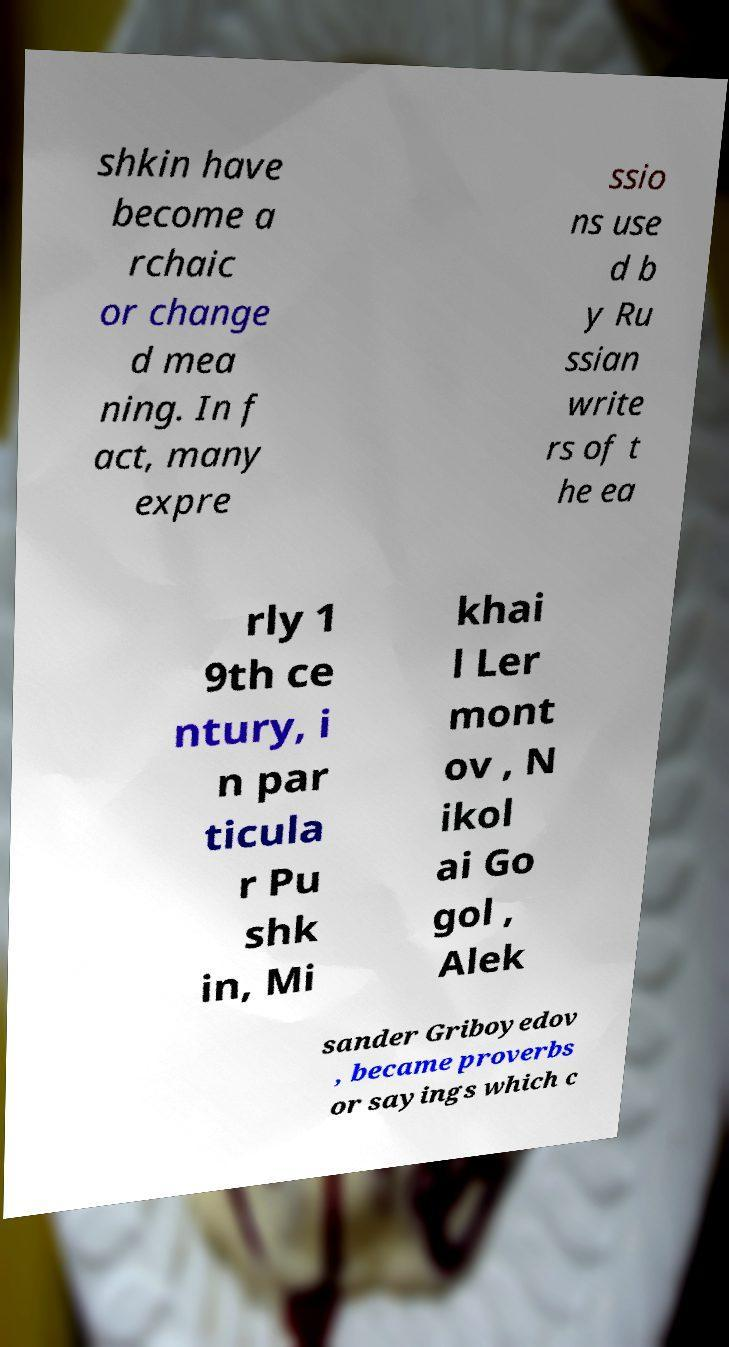Please read and relay the text visible in this image. What does it say? shkin have become a rchaic or change d mea ning. In f act, many expre ssio ns use d b y Ru ssian write rs of t he ea rly 1 9th ce ntury, i n par ticula r Pu shk in, Mi khai l Ler mont ov , N ikol ai Go gol , Alek sander Griboyedov , became proverbs or sayings which c 